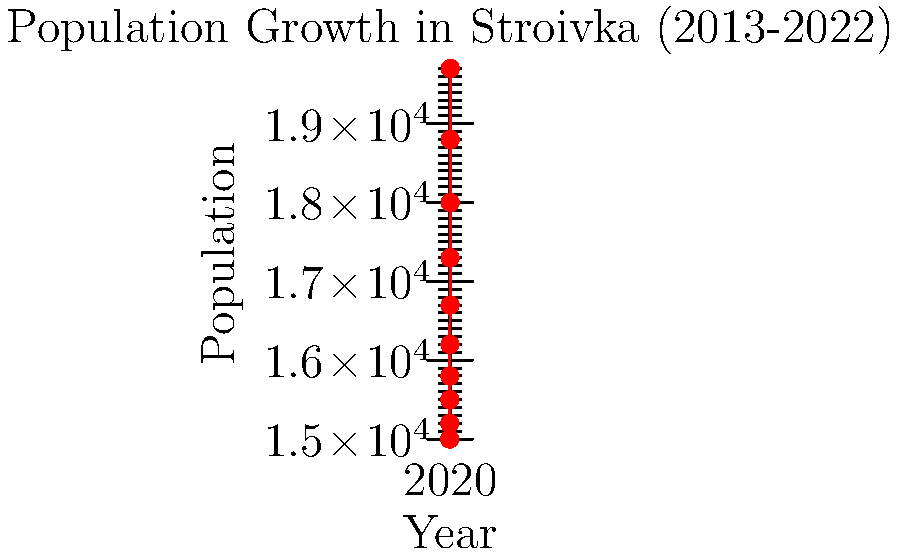Based on the line graph showing Stroivka's population growth from 2013 to 2022, what was the approximate increase in population over this decade? To determine the population increase over the decade, we need to follow these steps:

1. Identify the population at the start (2013) and end (2022) of the period:
   - 2013 population: approximately 15,000
   - 2022 population: approximately 19,700

2. Calculate the difference between these two values:
   $19,700 - 15,000 = 4,700$

3. This difference represents the total population increase over the decade.

The graph shows a steady upward trend, indicating consistent growth throughout the period. This growth trend aligns with the persona's hopeful outlook for Stroivka's future, as the town has experienced significant population increase over the past decade.
Answer: Approximately 4,700 